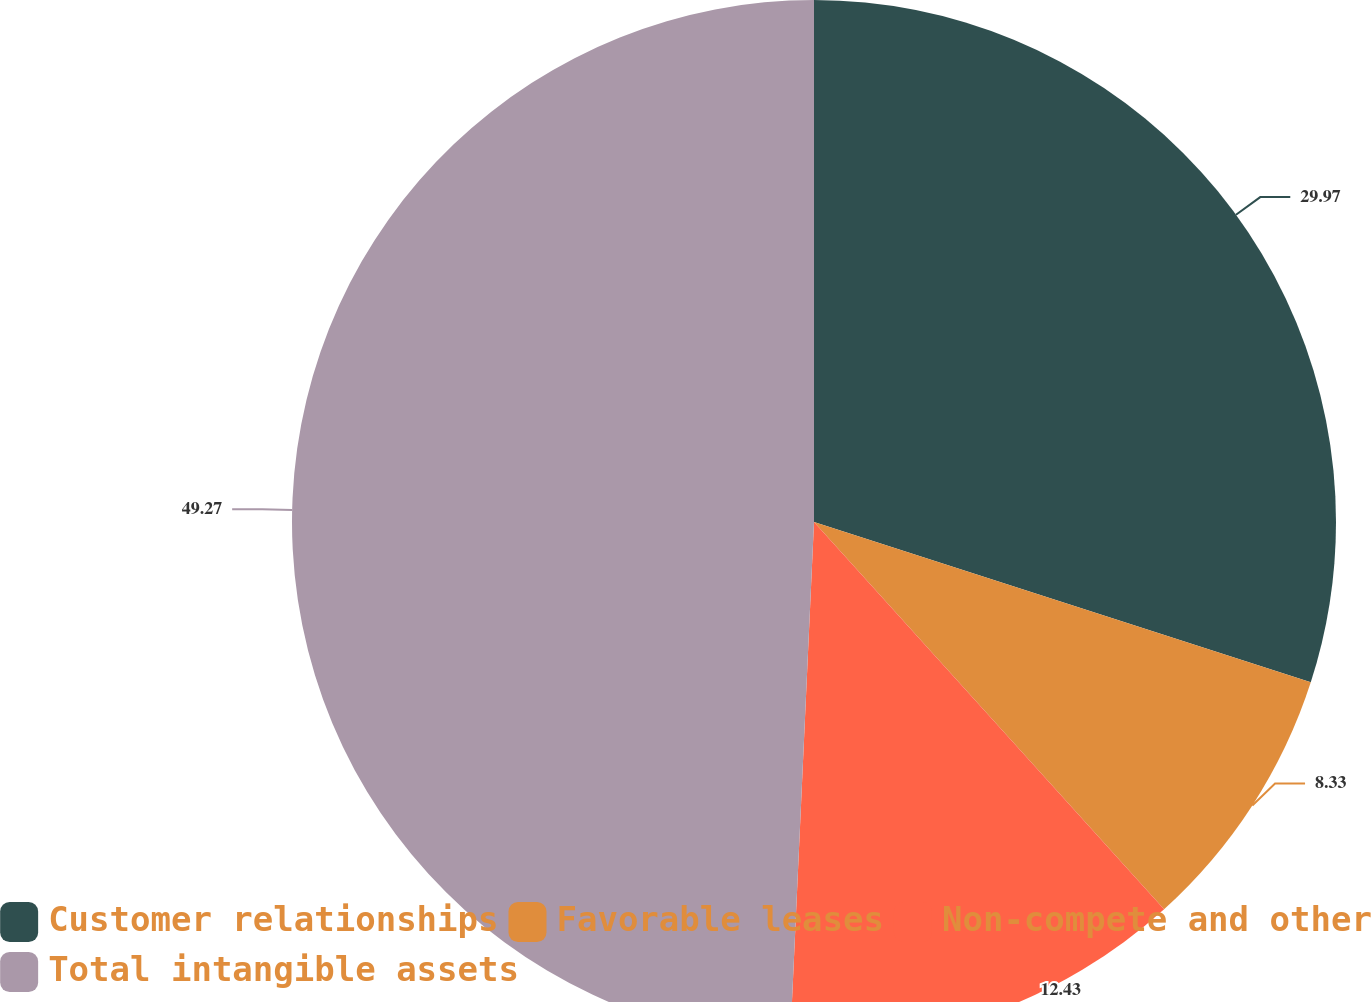Convert chart to OTSL. <chart><loc_0><loc_0><loc_500><loc_500><pie_chart><fcel>Customer relationships<fcel>Favorable leases<fcel>Non-compete and other<fcel>Total intangible assets<nl><fcel>29.97%<fcel>8.33%<fcel>12.43%<fcel>49.27%<nl></chart> 